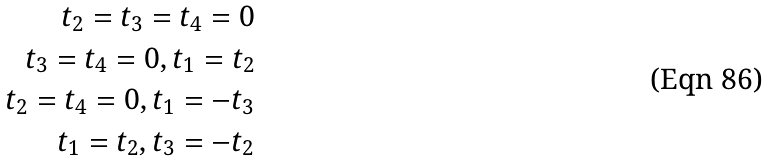Convert formula to latex. <formula><loc_0><loc_0><loc_500><loc_500>t _ { 2 } = t _ { 3 } = t _ { 4 } = 0 \\ t _ { 3 } = t _ { 4 } = 0 , t _ { 1 } = t _ { 2 } \\ t _ { 2 } = t _ { 4 } = 0 , t _ { 1 } = - t _ { 3 } \\ t _ { 1 } = t _ { 2 } , t _ { 3 } = - t _ { 2 }</formula> 